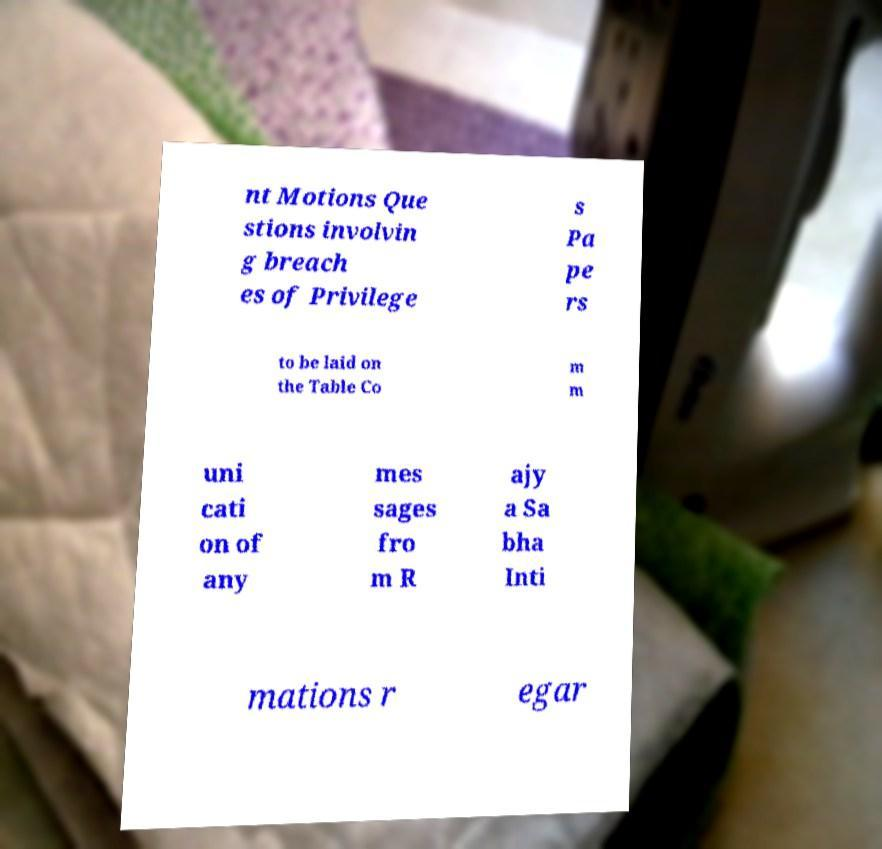Can you accurately transcribe the text from the provided image for me? nt Motions Que stions involvin g breach es of Privilege s Pa pe rs to be laid on the Table Co m m uni cati on of any mes sages fro m R ajy a Sa bha Inti mations r egar 